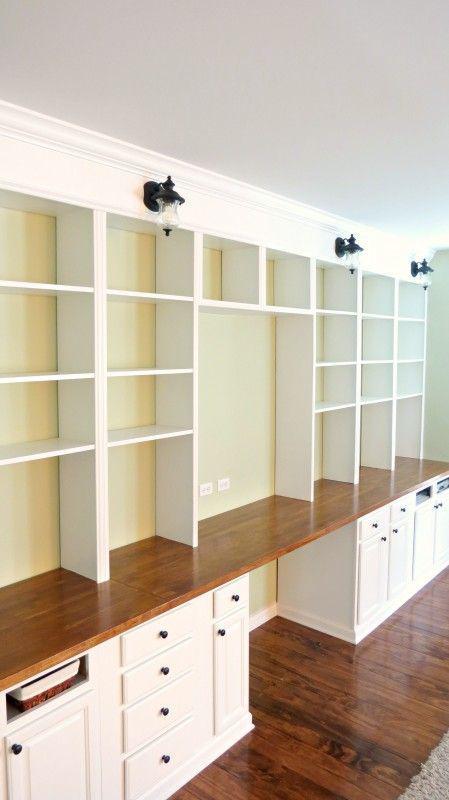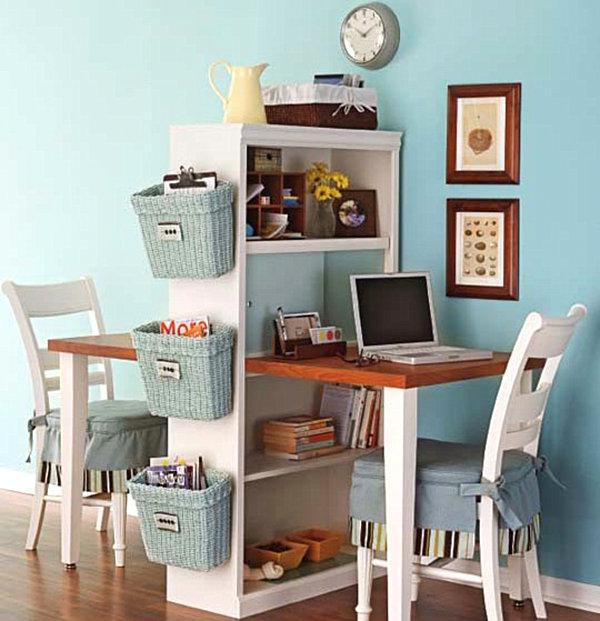The first image is the image on the left, the second image is the image on the right. For the images shown, is this caption "A window is behind a white desk with a desktop computer on it and a bookshelf component against a wall." true? Answer yes or no. No. The first image is the image on the left, the second image is the image on the right. Given the left and right images, does the statement "A desk unit in one image is comprised of a bookcase with four shelves at one end and a two-shelf bookcase at the other end, with a desktop extending between them." hold true? Answer yes or no. No. 